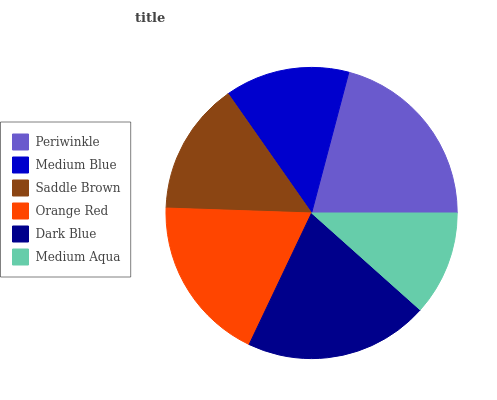Is Medium Aqua the minimum?
Answer yes or no. Yes. Is Periwinkle the maximum?
Answer yes or no. Yes. Is Medium Blue the minimum?
Answer yes or no. No. Is Medium Blue the maximum?
Answer yes or no. No. Is Periwinkle greater than Medium Blue?
Answer yes or no. Yes. Is Medium Blue less than Periwinkle?
Answer yes or no. Yes. Is Medium Blue greater than Periwinkle?
Answer yes or no. No. Is Periwinkle less than Medium Blue?
Answer yes or no. No. Is Orange Red the high median?
Answer yes or no. Yes. Is Saddle Brown the low median?
Answer yes or no. Yes. Is Periwinkle the high median?
Answer yes or no. No. Is Orange Red the low median?
Answer yes or no. No. 